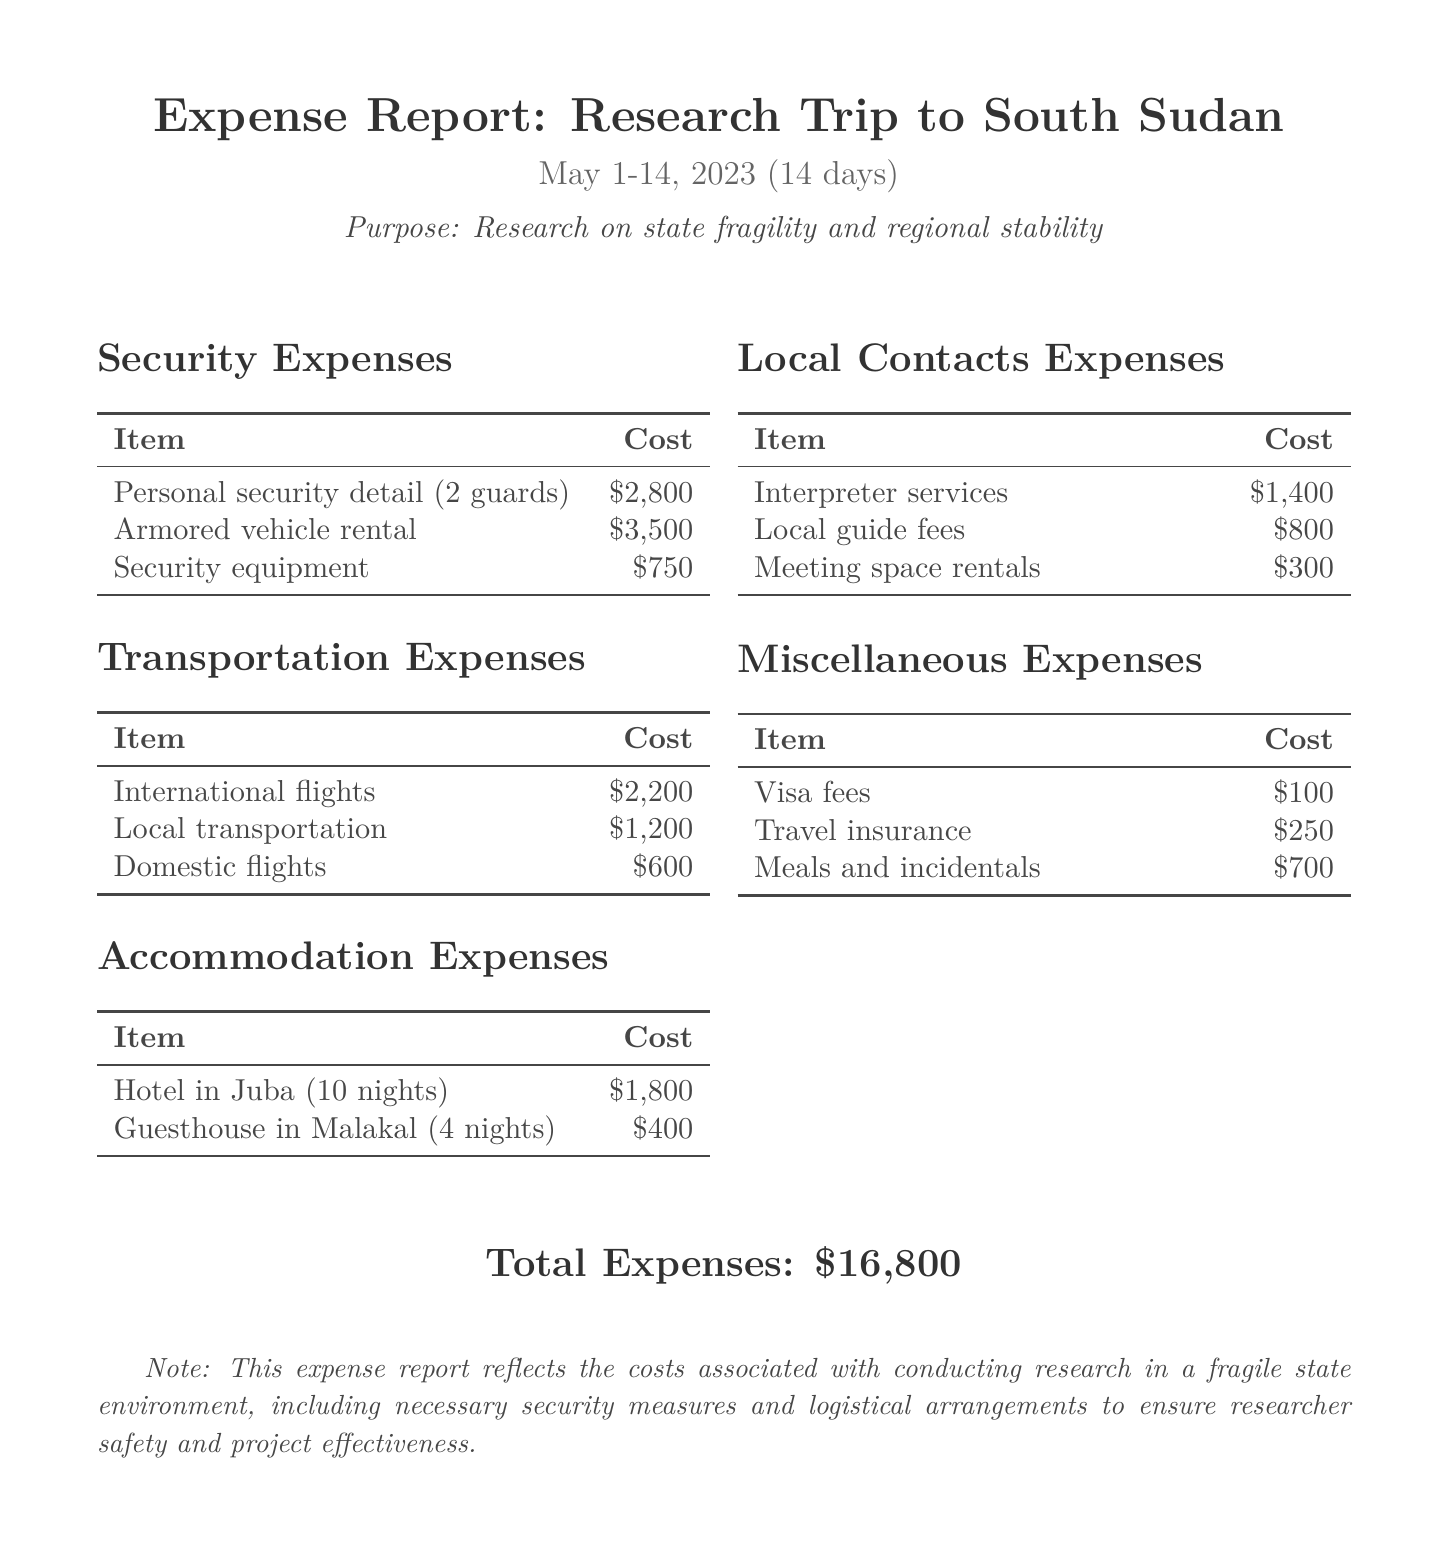What is the purpose of the research trip? The purpose is stated in the document as research on state fragility and regional stability.
Answer: Research on state fragility and regional stability How much was spent on personal security detail? The document lists the cost for personal security detail under security expenses.
Answer: $2,800 What was the cost of local transportation? The cost for local transportation is specified in the transportation expenses section.
Answer: $1,200 How many nights was the hotel in Juba booked for? The document details the accommodation expenses, including the duration of the hotel stay.
Answer: 10 nights What is the total cost for accommodation expenses? The total accommodation expenses can be calculated by adding the costs for the hotel and guesthouse.
Answer: $2,200 How many local guide fees were incurred? The document specifies the fees related to local guides under local contacts expenses.
Answer: $800 What was the total amount spent on security expenses? To find the total, add all security-related costs outlined in the document.
Answer: $7,050 What type of document is this? The document categorizes itself as an expense report related to a research trip.
Answer: Expense Report What were the visa fees? The visa fees are listed under miscellaneous expenses in the document.
Answer: $100 